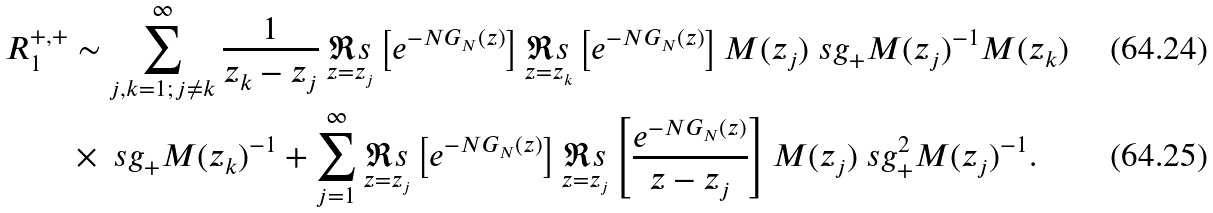<formula> <loc_0><loc_0><loc_500><loc_500>R _ { 1 } ^ { + , + } & \sim \sum _ { j , k = 1 ; \, j \not = k } ^ { \infty } \frac { 1 } { z _ { k } - z _ { j } } \, \underset { z = z _ { j } } { \Re s } \left [ e ^ { - N G _ { N } ( z ) } \right ] \underset { z = z _ { k } } { \Re s } \left [ e ^ { - N G _ { N } ( z ) } \right ] M ( z _ { j } ) \ s g _ { + } M ( z _ { j } ) ^ { - 1 } M ( z _ { k } ) \\ & \times \ s g _ { + } M ( z _ { k } ) ^ { - 1 } + \sum _ { j = 1 } ^ { \infty } \underset { z = z _ { j } } { \Re s } \left [ e ^ { - N G _ { N } ( z ) } \right ] \underset { z = z _ { j } } { \Re s } \left [ \frac { e ^ { - N G _ { N } ( z ) } } { z - z _ { j } } \right ] M ( z _ { j } ) \ s g _ { + } ^ { 2 } M ( z _ { j } ) ^ { - 1 } .</formula> 